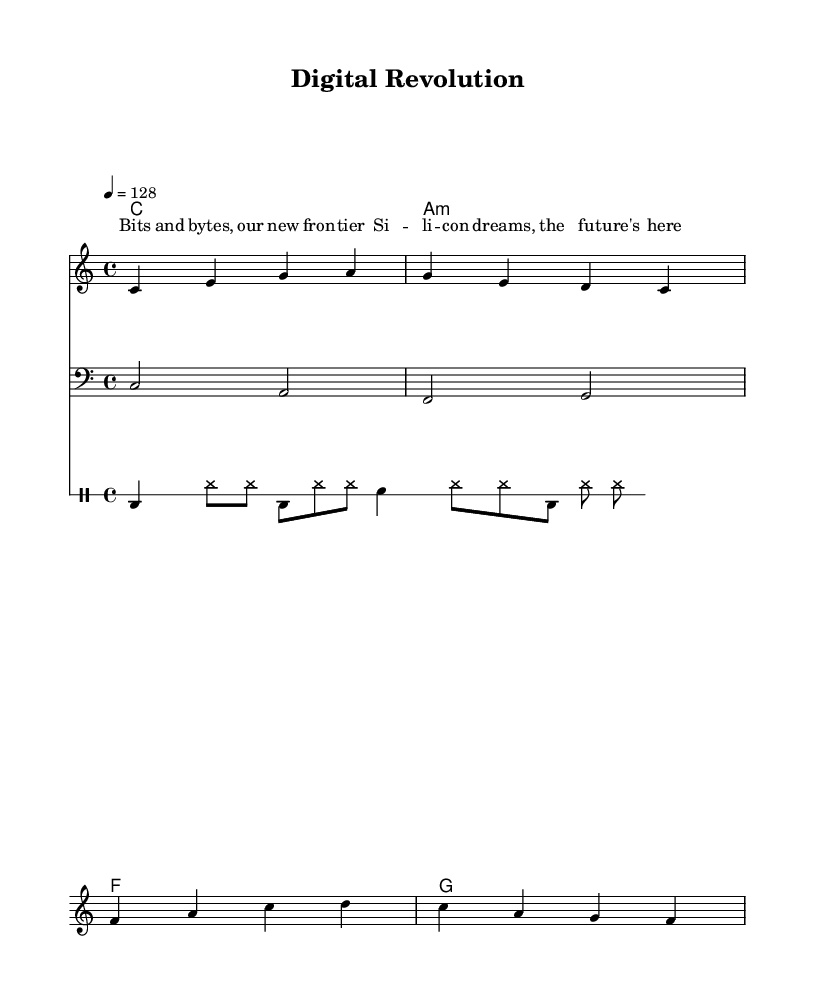What is the key signature of this music? The key signature is indicated at the beginning of the score, showing that it is in C major, which has no sharps or flats.
Answer: C major What is the time signature of this piece? The time signature is shown next to the key signature and indicates that there are four beats in a measure, which is typical for pop songs.
Answer: 4/4 What is the tempo marking of the song? The tempo is specified in the score with "4 = 128", meaning there should be 128 beats per minute, giving the song a lively pop feel.
Answer: 128 How many measures are in the melody? By counting the number of groups of notes separated by vertical lines (bar lines) in the melody part, we find there are a total of 8 measures.
Answer: 8 What is the chord progression used in the song? The chords are displayed in the chord mode section, showing a progression from C major to A minor, then F major, and G major.
Answer: C, A minor, F, G What instrument is the bass line notated for? The bass line is notated with a clef symbol that indicates it is written for a bass instrument, which typically plays lower notes.
Answer: Bass What thematic element does the lyric "Silicon dreams, the future's here" reflect? This lyric celebrates technological advancements and the impact of technology on society, which is a common theme in electronic-infused pop songs.
Answer: Technological advancements 